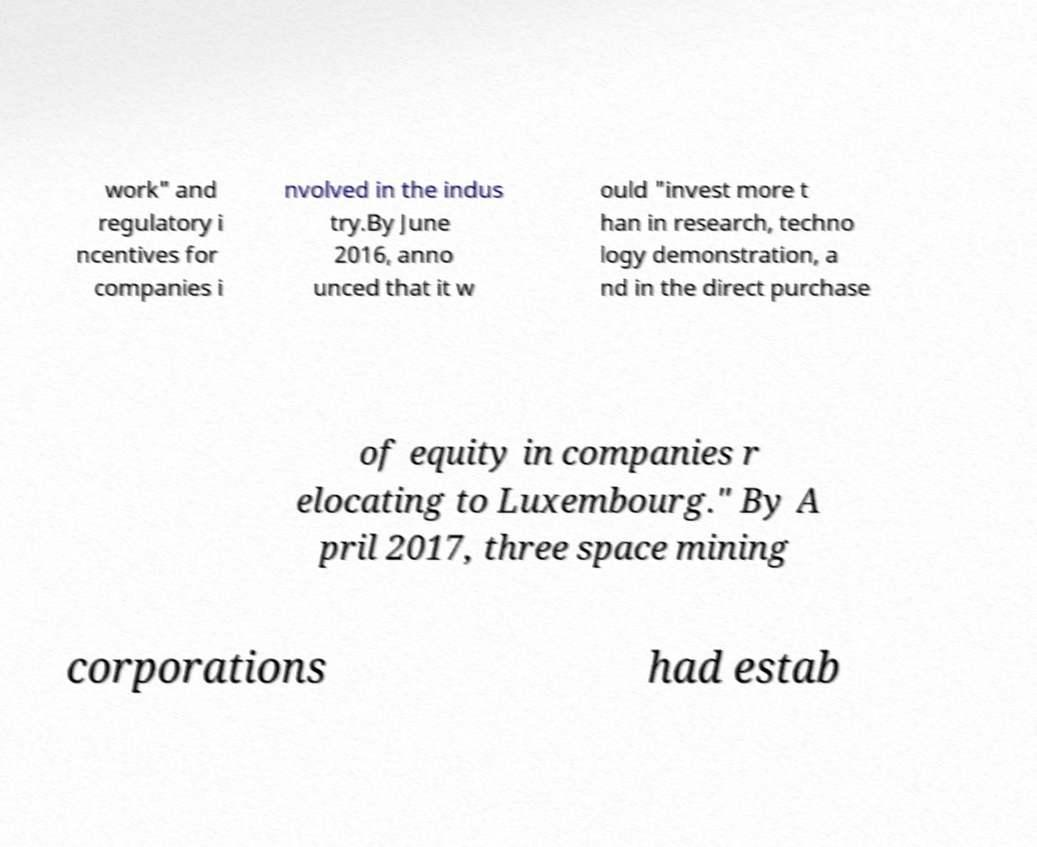Could you assist in decoding the text presented in this image and type it out clearly? work" and regulatory i ncentives for companies i nvolved in the indus try.By June 2016, anno unced that it w ould "invest more t han in research, techno logy demonstration, a nd in the direct purchase of equity in companies r elocating to Luxembourg." By A pril 2017, three space mining corporations had estab 